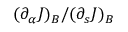<formula> <loc_0><loc_0><loc_500><loc_500>( \partial _ { \alpha } J ) _ { B } / ( \partial _ { s } J ) _ { B }</formula> 